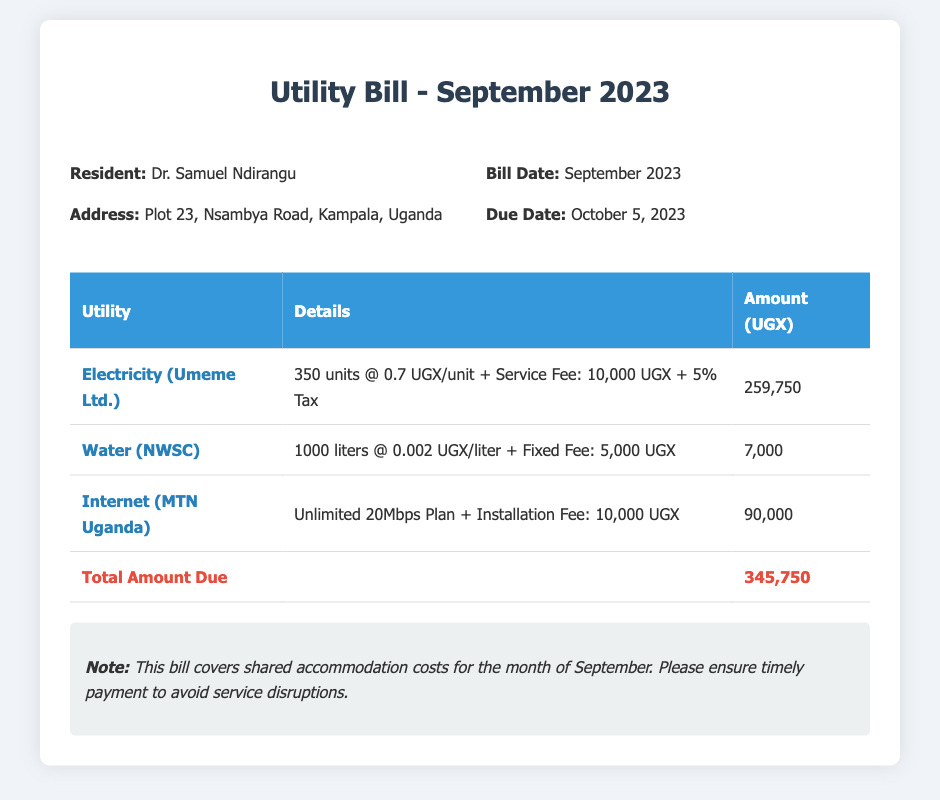What is the resident's name? The resident's name is mentioned in the document header.
Answer: Dr. Samuel Ndirangu What is the due date for the bill? The due date is specified under the bill information section.
Answer: October 5, 2023 How much was charged for electricity? The charge for electricity is detailed in the utility table.
Answer: 259,750 What is the total amount due? The total due is provided in the last row of the utility table.
Answer: 345,750 What is the fixed fee for water? The fixed fee for water is included in the water charge details.
Answer: 5,000 What service provider is listed for internet? The internet service provider is mentioned in the utility table.
Answer: MTN Uganda How many units of electricity were consumed? The units consumed for electricity are specified in the consumption details.
Answer: 350 units What is the additional fee included in the electricity charge? The additional fee is mentioned alongside the electricity charge.
Answer: Service Fee: 10,000 UGX What is the note regarding payment? The note is included at the bottom of the document.
Answer: Ensure timely payment to avoid service disruptions 